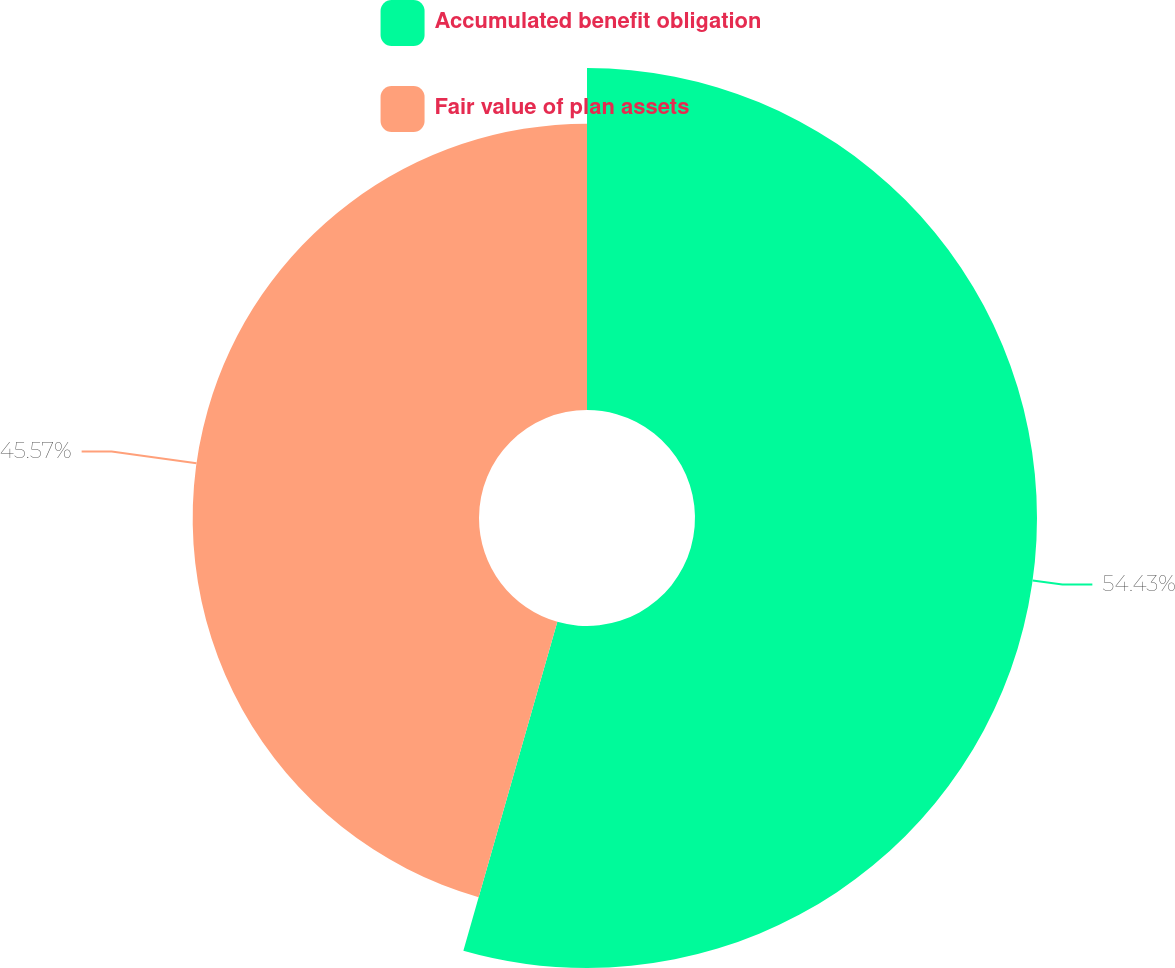Convert chart to OTSL. <chart><loc_0><loc_0><loc_500><loc_500><pie_chart><fcel>Accumulated benefit obligation<fcel>Fair value of plan assets<nl><fcel>54.43%<fcel>45.57%<nl></chart> 